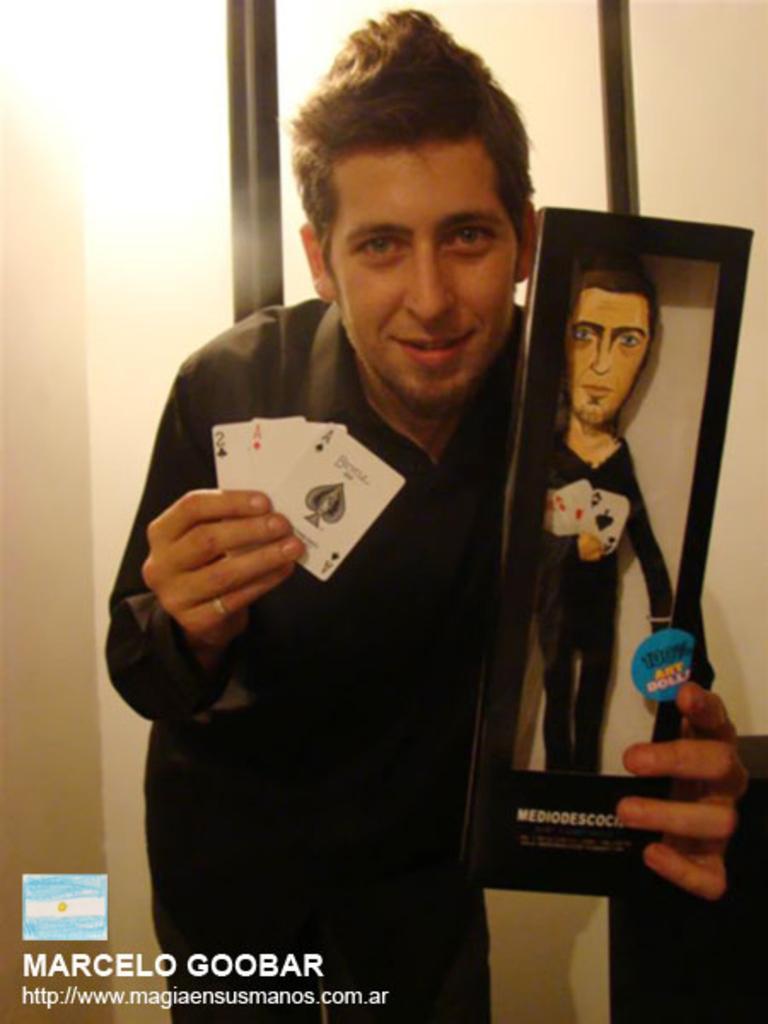Could you give a brief overview of what you see in this image? On the bottom right, there is a watermark. In the middle of this image, there is a person in a black color dress, holding a card with a hand and holding a box, which is containing a doll with the other hand and smiling. In the background, there is a wall. 